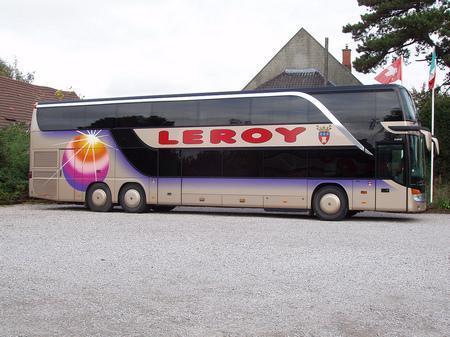How many doors in this?
Give a very brief answer. 1. 